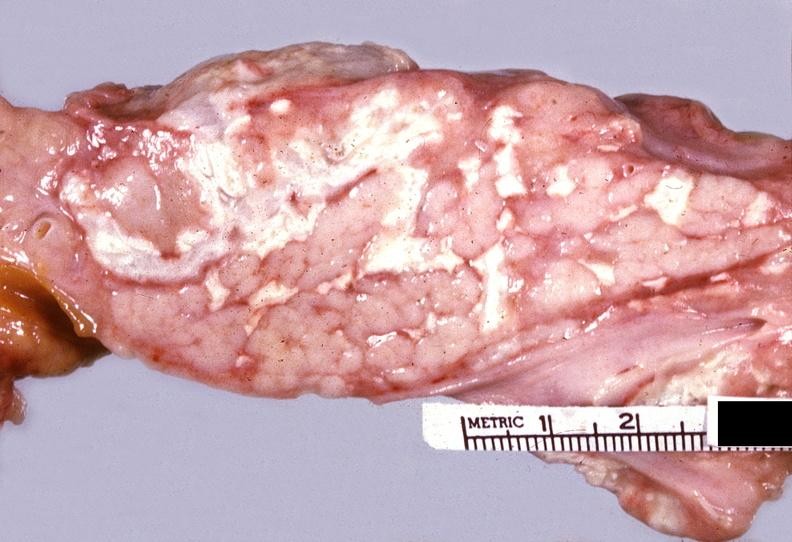does postpartum show acute pancreatitis?
Answer the question using a single word or phrase. No 